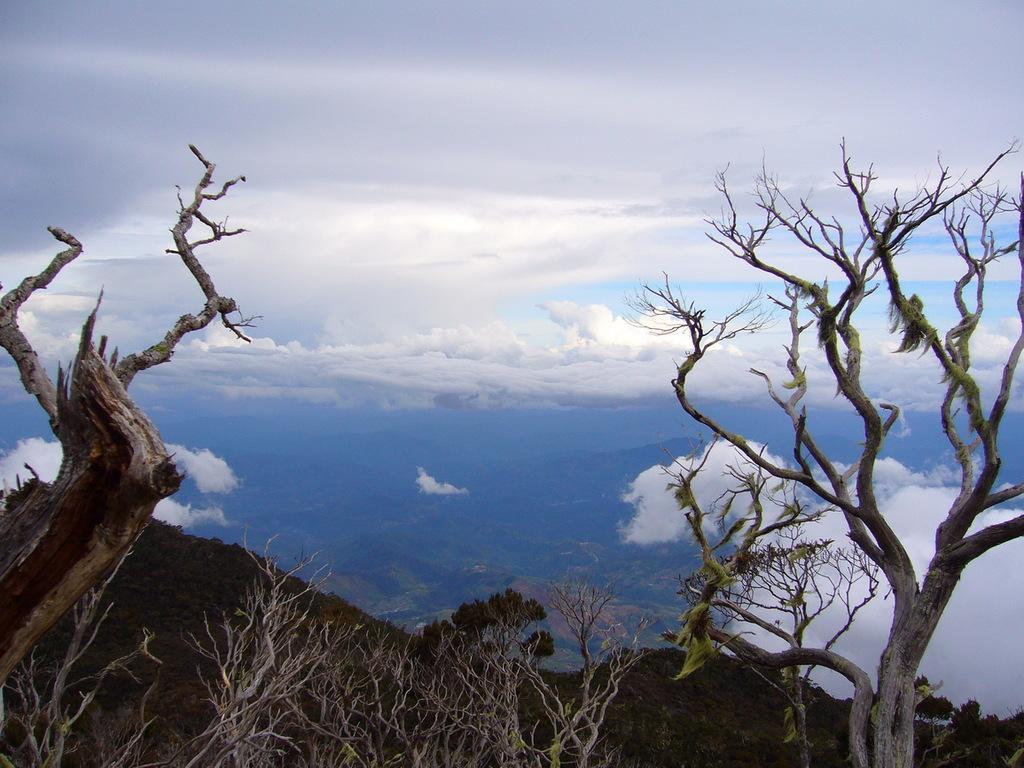Could you give a brief overview of what you see in this image? Here we can see bare trees. In the background there are mountains and clouds in the sky. 